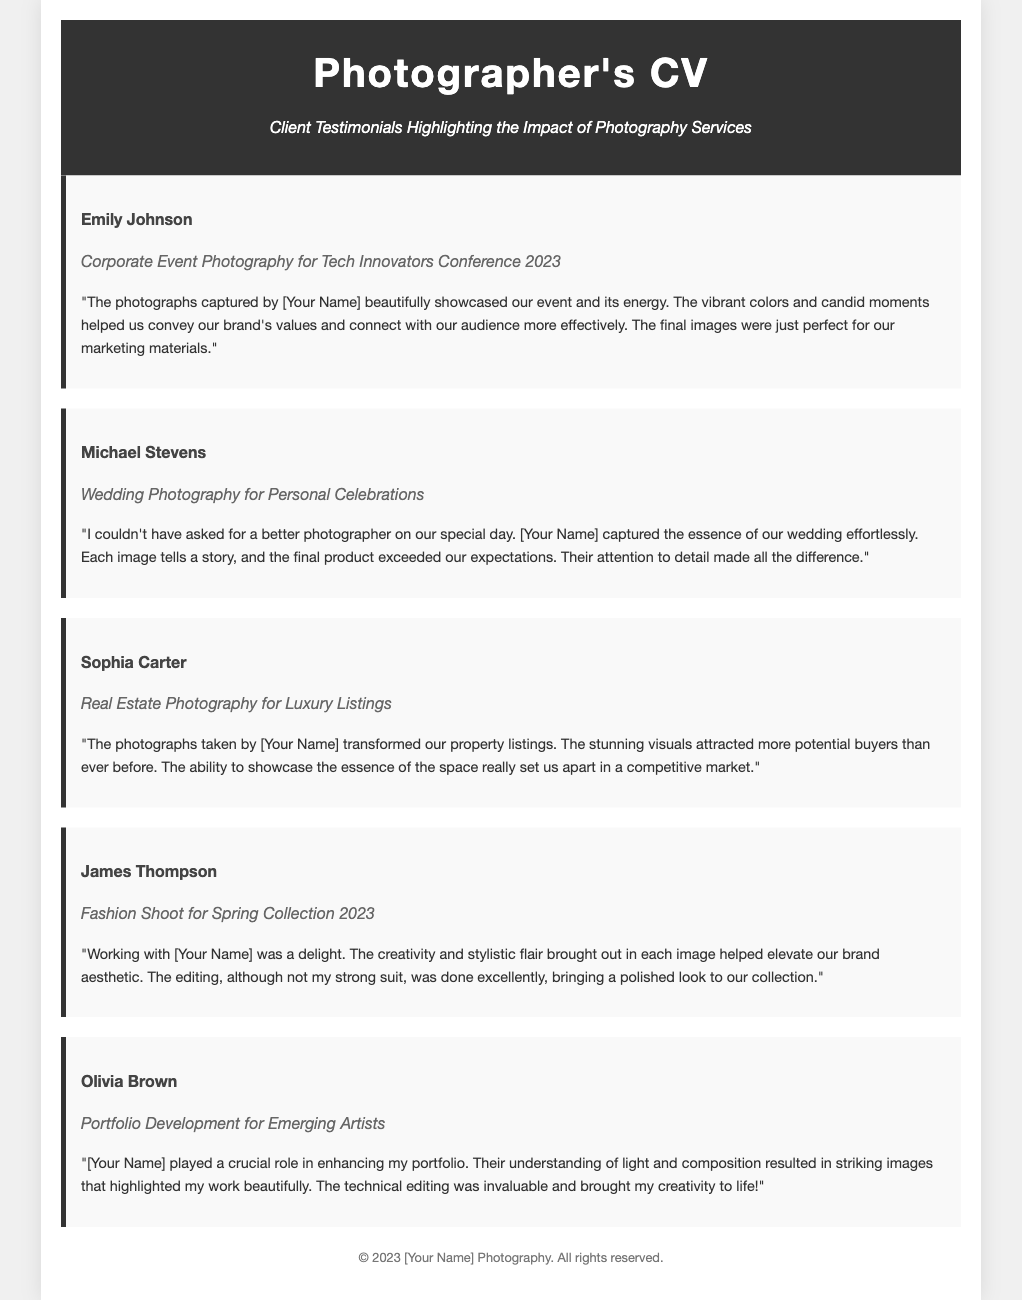What is the name of the first client testimonial? The first client testimonial is from Emily Johnson, as mentioned in the document.
Answer: Emily Johnson What is the project type associated with Michael Stevens? Michael Stevens provided a testimonial regarding Wedding Photography for Personal Celebrations.
Answer: Wedding Photography What key aspect did Sophia Carter highlight about the photographs? Sophia Carter emphasized that the photographs transformed their property listings and attracted more potential buyers.
Answer: Transformed property listings Who expressed satisfaction with the attention to detail? The client who expressed satisfaction with the attention to detail was Michael Stevens.
Answer: Michael Stevens What year was the Fashion Shoot for Spring Collection conducted? The Fashion Shoot for Spring Collection took place in the year 2023, as stated in the document.
Answer: 2023 Which photographer role contributed to Olivia Brown’s portfolio development? The role of [Your Name] played a crucial role in enhancing Olivia Brown's portfolio, according to her testimonial.
Answer: [Your Name] What was a common theme noted in the testimonials concerning the final images? A common theme noted in the testimonials is the quality and effectiveness of the final images for marketing and appeal.
Answer: Quality and effectiveness How many testimonials are included in the document? The document contains a total of five testimonials from different clients.
Answer: Five What style of photography did James Thompson praise? James Thompson praised the fashion photography style as it elevated their brand aesthetic.
Answer: Fashion Photography 